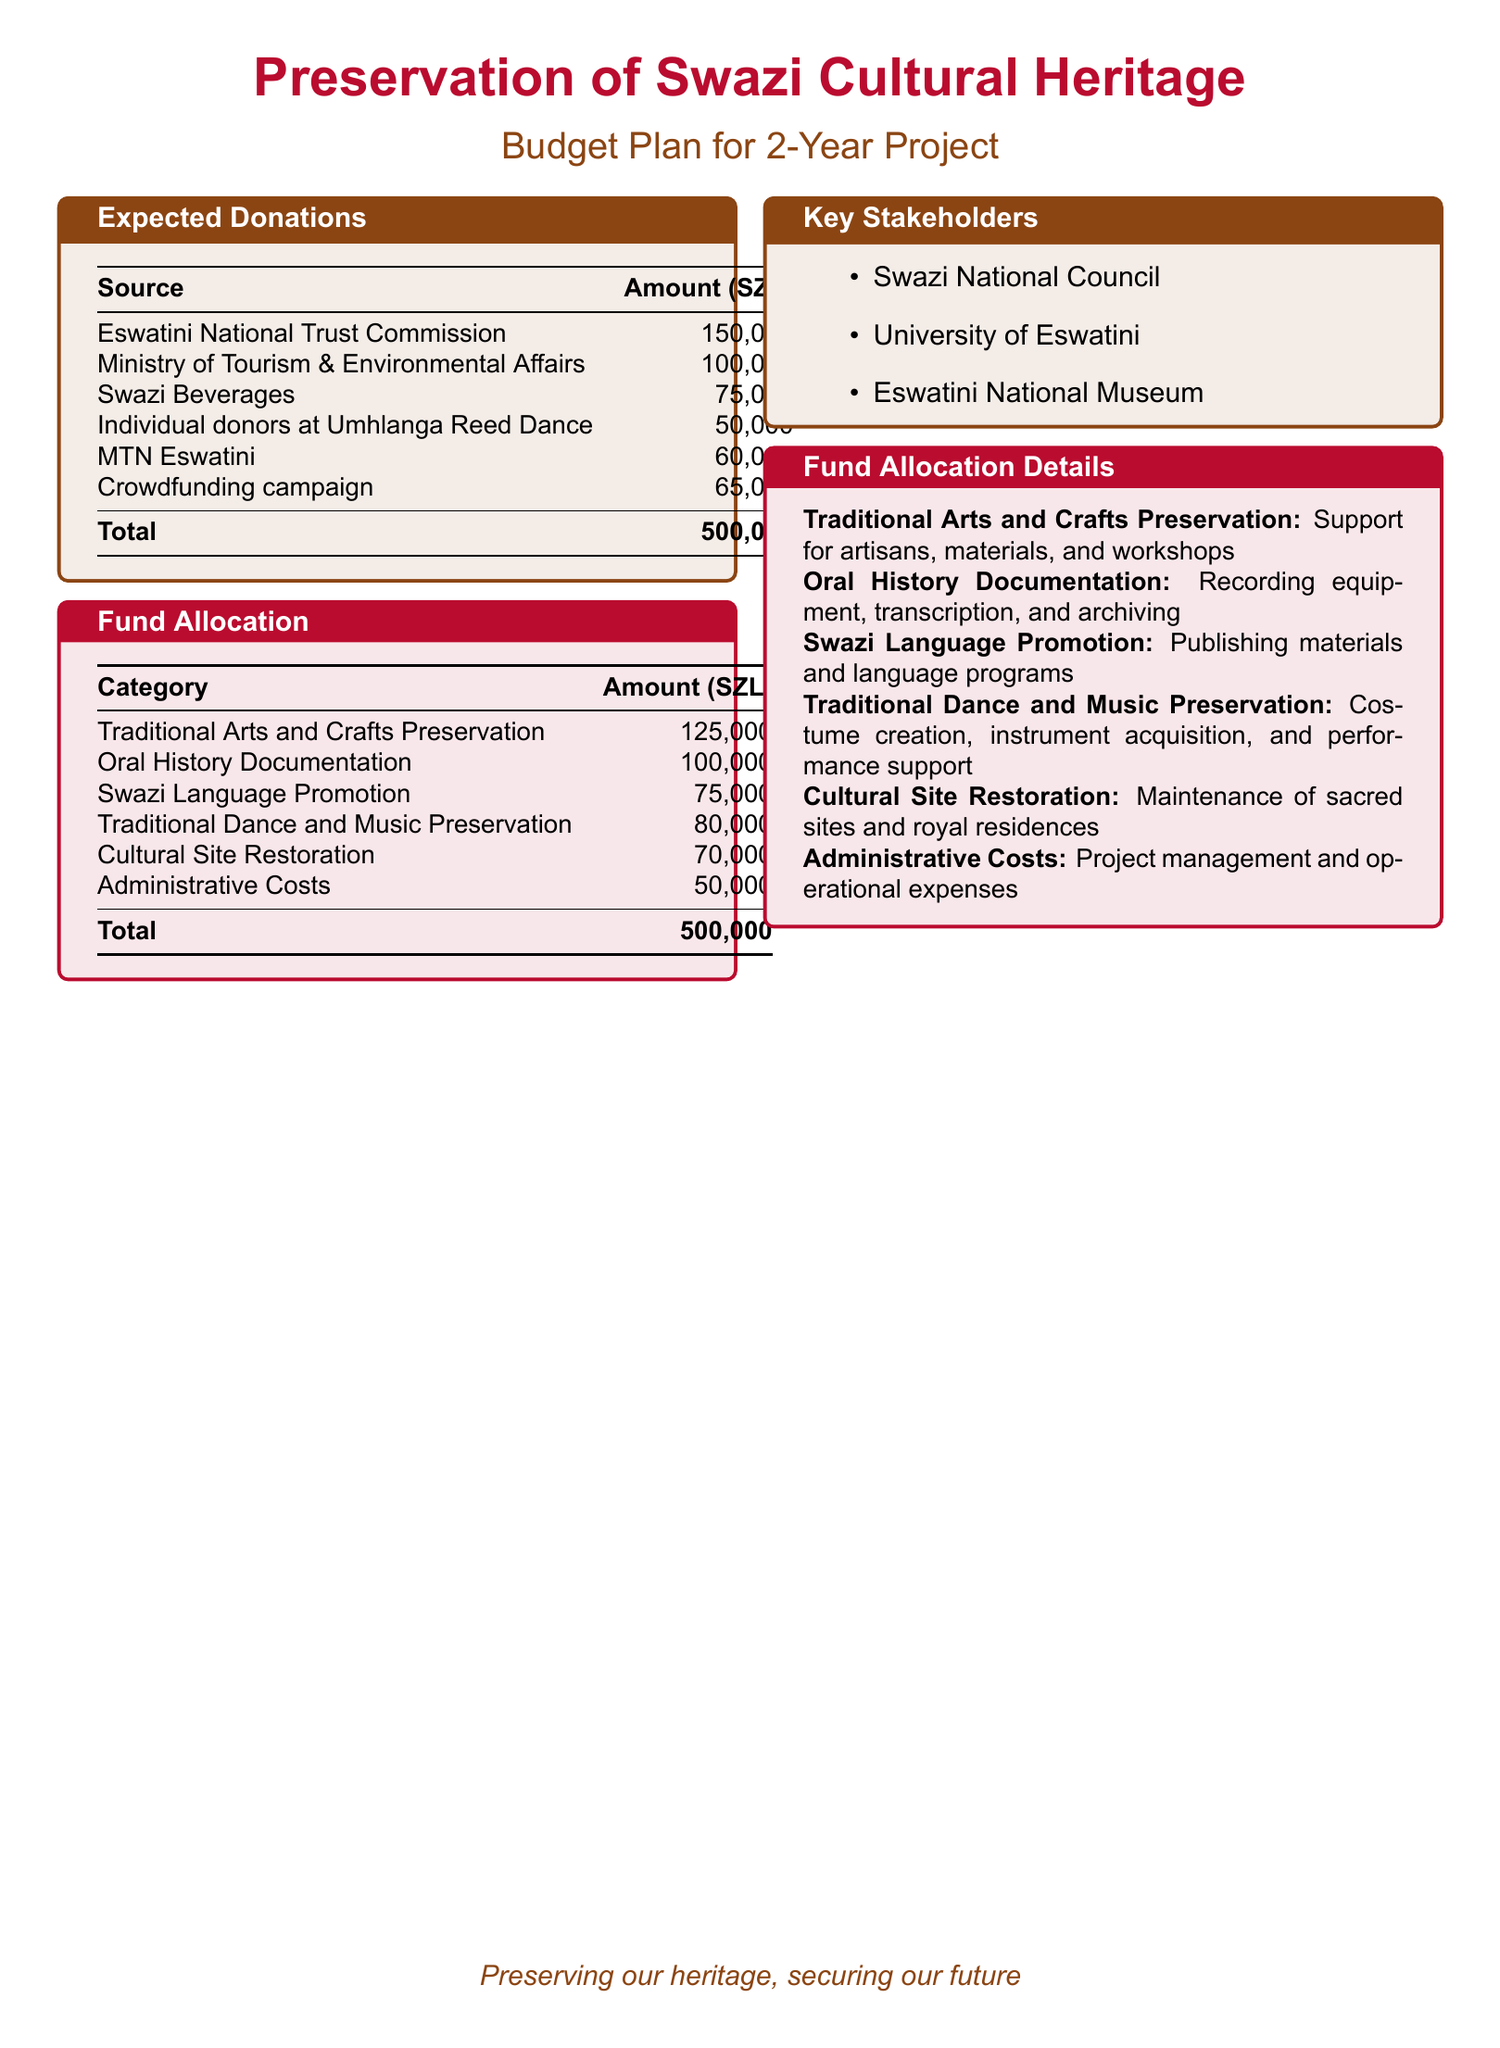What is the total expected donations? The total expected donations are listed in the document and sum up all the individual sources, which equals 500,000 SZL.
Answer: 500,000 SZL What is the amount allocated for Oral History Documentation? The document specifies the allocated amount for Oral History Documentation, which is 100,000 SZL.
Answer: 100,000 SZL Which organization donated 75,000 SZL? The document states that Swazi Beverages is the organization that donated 75,000 SZL.
Answer: Swazi Beverages What is the budget for Traditional Arts and Crafts Preservation? The budget for Traditional Arts and Crafts Preservation is found within the fund allocation section, amounting to 125,000 SZL.
Answer: 125,000 SZL Who is responsible for the project management and operational expenses? The document details that Administrative Costs, which cover project management and operational expenses, are allocated 50,000 SZL.
Answer: Administrative Costs What percentage of total donations comes from the Eswatini National Trust Commission? To find the percentage, divide the donation from Eswatini National Trust Commission (150,000) by total donations (500,000) and multiply by 100, resulting in 30%.
Answer: 30% Which stakeholder is associated with the University of Eswatini? The document indicates that one of the key stakeholders listed is the University of Eswatini.
Answer: University of Eswatini How much is designated for Cultural Site Restoration? The amount designated for Cultural Site Restoration is stated in the fund allocation, which is 70,000 SZL.
Answer: 70,000 SZL What is included in the Traditional Dance and Music Preservation budget? The document mentions that Traditional Dance and Music Preservation includes expenses for costume creation, instrument acquisition, and performance support.
Answer: Costume creation, instrument acquisition, and performance support 